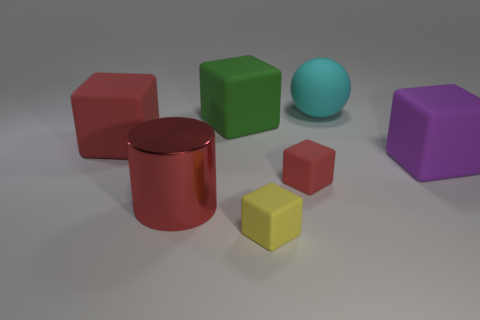Subtract 1 blocks. How many blocks are left? 4 Subtract all yellow matte cubes. How many cubes are left? 4 Subtract all purple cubes. How many cubes are left? 4 Subtract all cyan blocks. Subtract all green cylinders. How many blocks are left? 5 Add 1 big cyan rubber spheres. How many objects exist? 8 Subtract all cubes. How many objects are left? 2 Subtract all large cyan things. Subtract all large gray metal blocks. How many objects are left? 6 Add 5 tiny red cubes. How many tiny red cubes are left? 6 Add 4 yellow things. How many yellow things exist? 5 Subtract 0 blue cylinders. How many objects are left? 7 